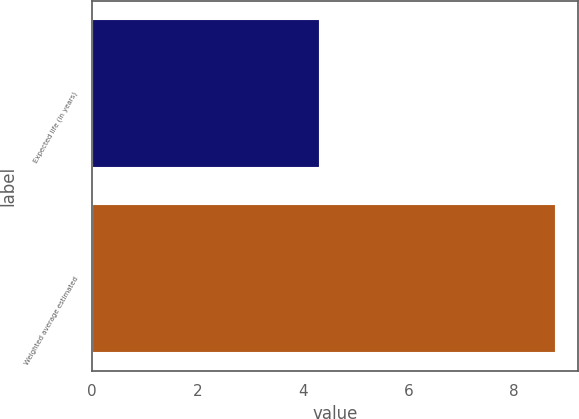Convert chart. <chart><loc_0><loc_0><loc_500><loc_500><bar_chart><fcel>Expected life (in years)<fcel>Weighted average estimated<nl><fcel>4.3<fcel>8.77<nl></chart> 